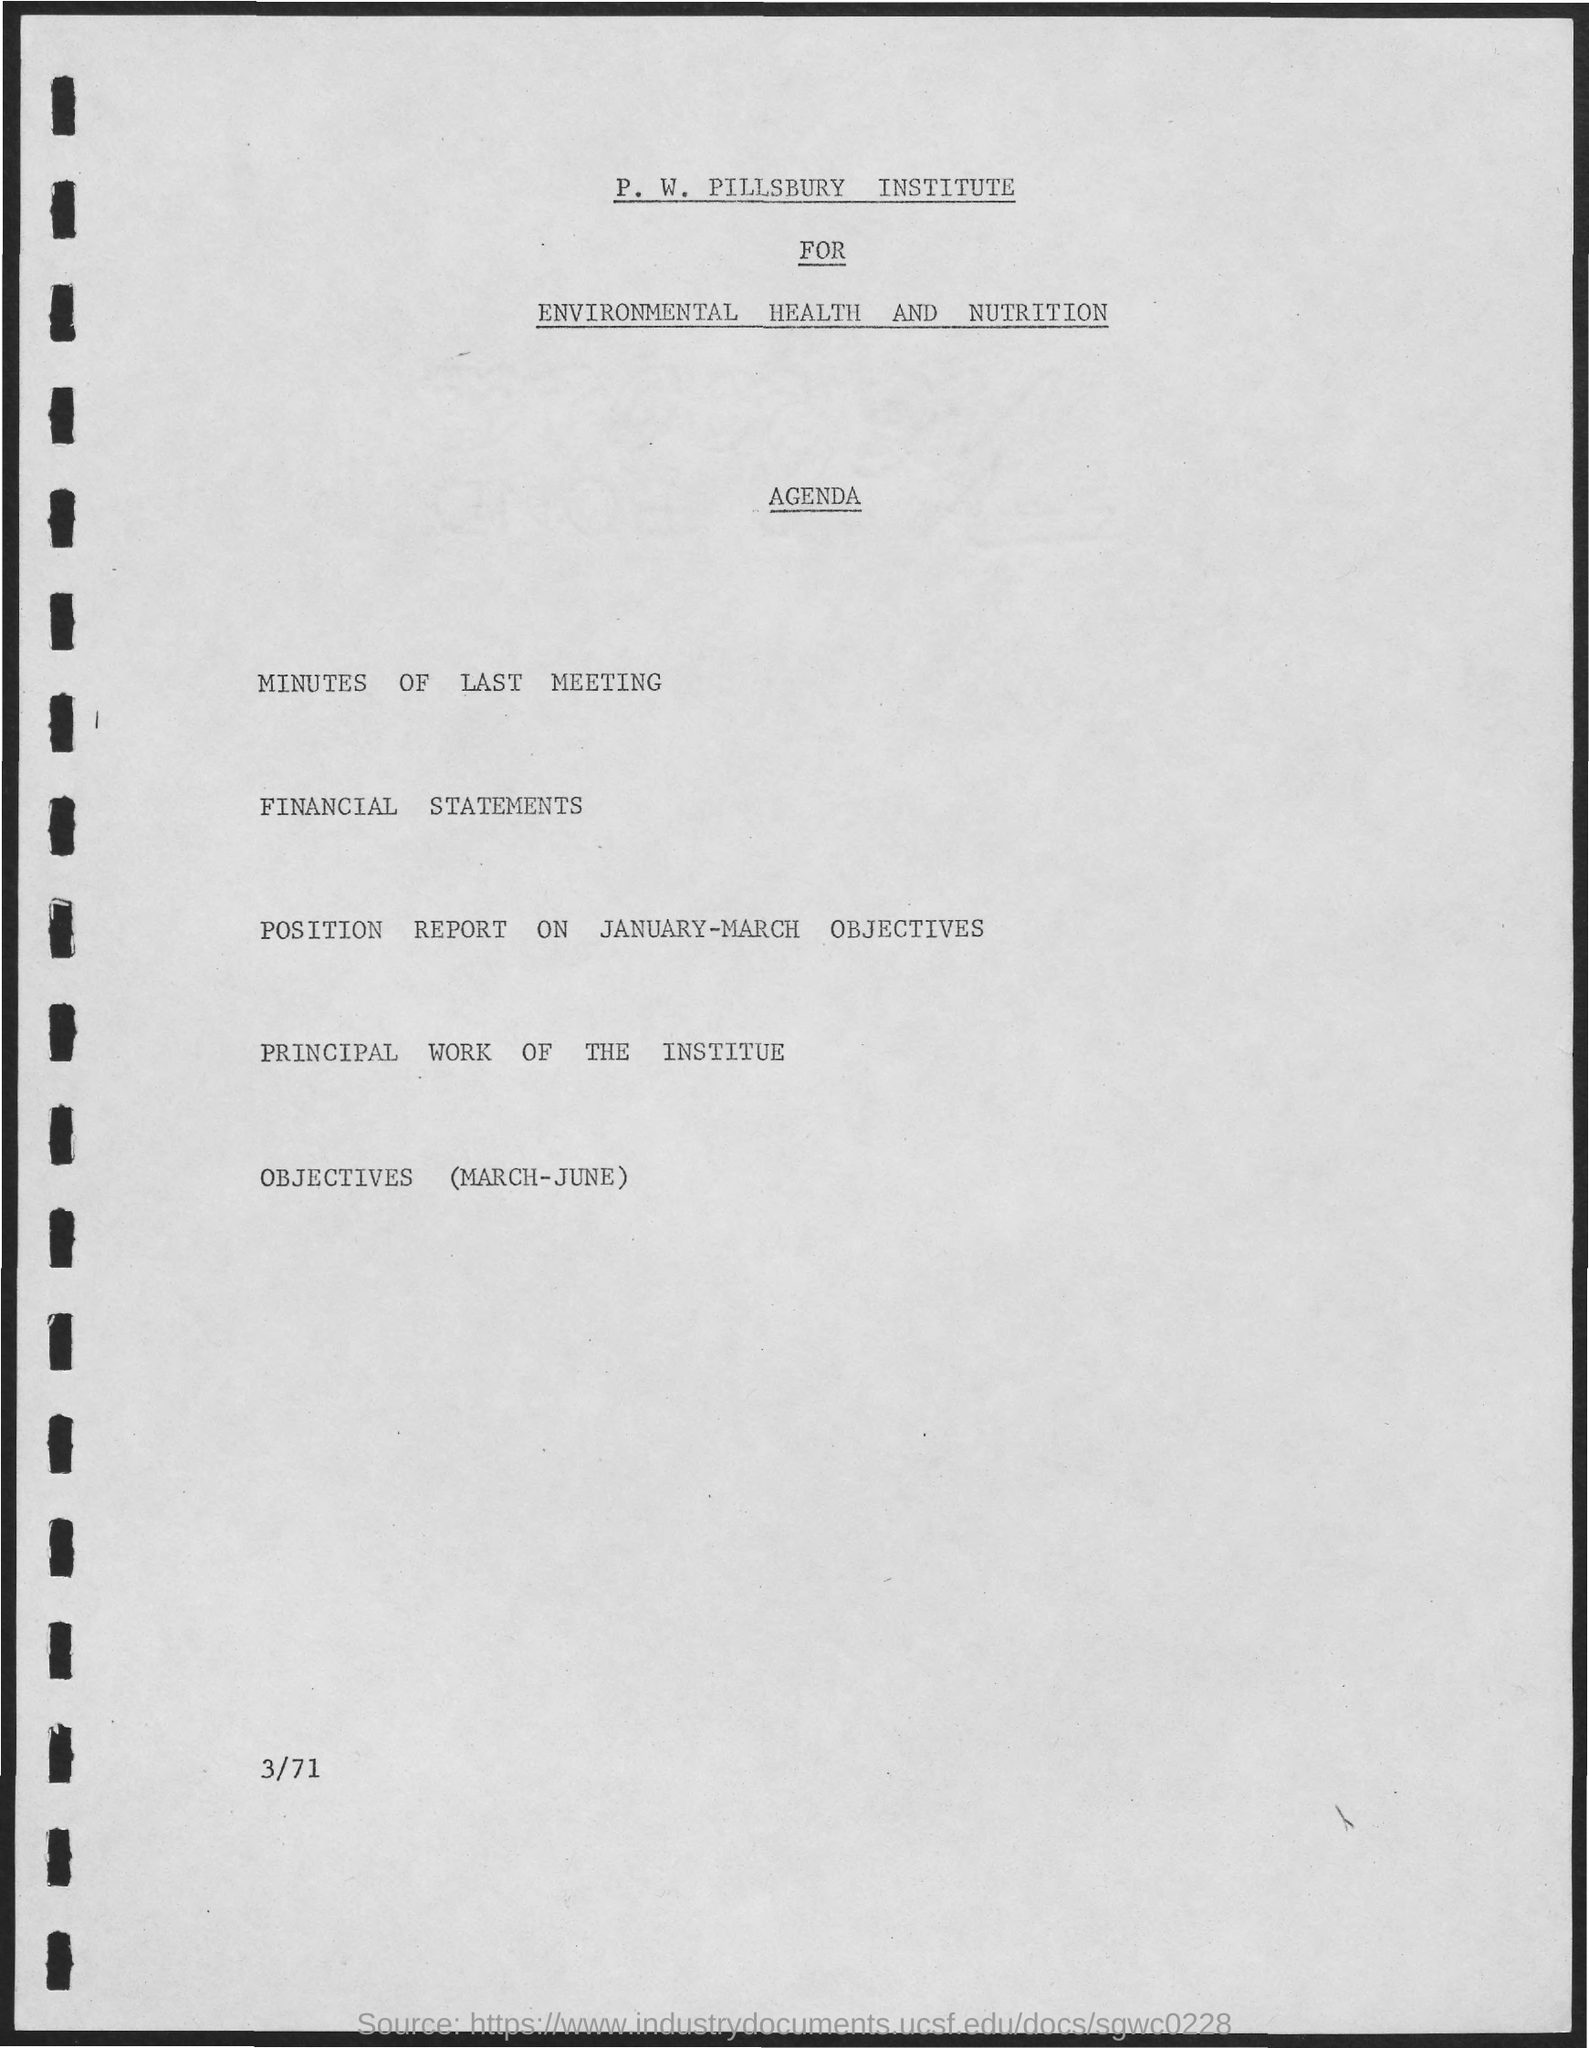Outline some significant characteristics in this image. The second title in the document is 'Agenda,' The P. W. Pillsbury Institute is the first title in the document. 